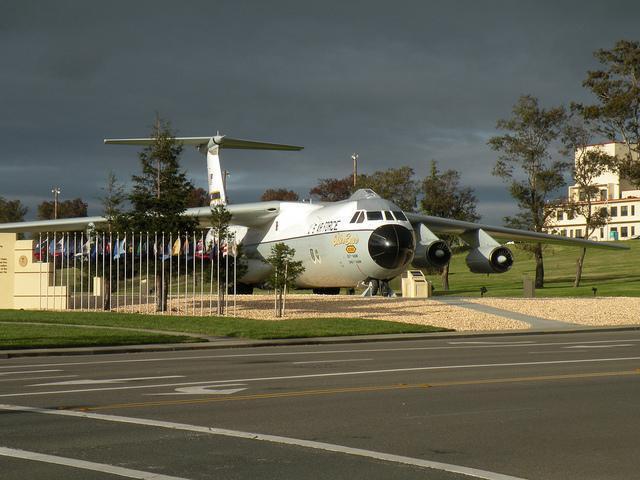How many airplanes are in the picture?
Give a very brief answer. 1. How many donuts have blue color cream?
Give a very brief answer. 0. 